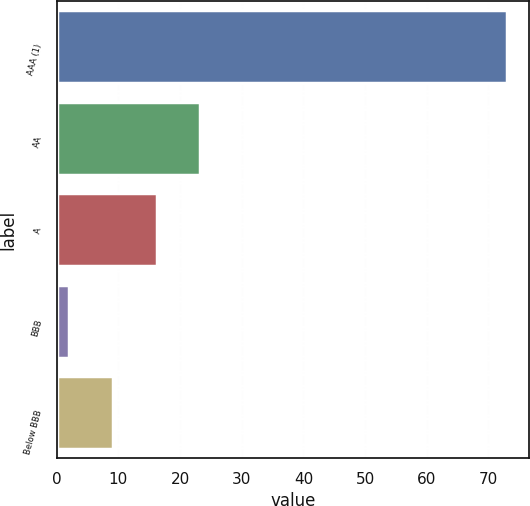<chart> <loc_0><loc_0><loc_500><loc_500><bar_chart><fcel>AAA (1)<fcel>AA<fcel>A<fcel>BBB<fcel>Below BBB<nl><fcel>73<fcel>23.3<fcel>16.2<fcel>2<fcel>9.1<nl></chart> 